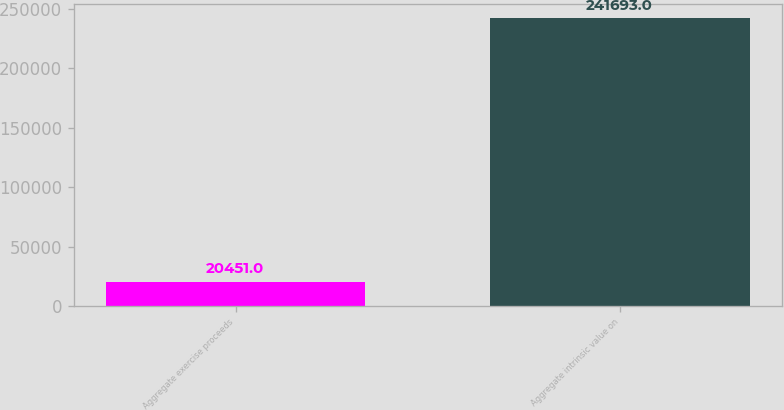Convert chart. <chart><loc_0><loc_0><loc_500><loc_500><bar_chart><fcel>Aggregate exercise proceeds<fcel>Aggregate intrinsic value on<nl><fcel>20451<fcel>241693<nl></chart> 